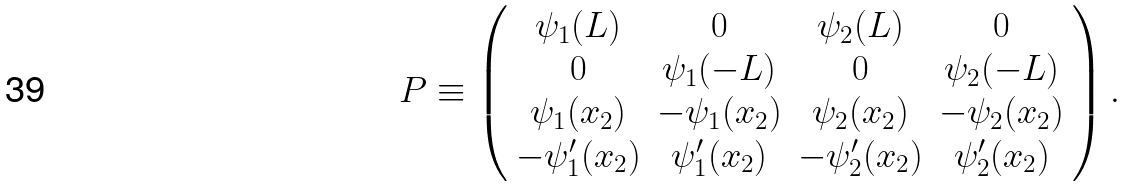Convert formula to latex. <formula><loc_0><loc_0><loc_500><loc_500>P \equiv \left ( \begin{array} { c c c c } \psi _ { 1 } ( L ) & 0 & \psi _ { 2 } ( L ) & 0 \\ 0 & \psi _ { 1 } ( - L ) & 0 & \psi _ { 2 } ( - L ) \\ \psi _ { 1 } ( x _ { 2 } ) & - \psi _ { 1 } ( x _ { 2 } ) & \psi _ { 2 } ( x _ { 2 } ) & - \psi _ { 2 } ( x _ { 2 } ) \\ - \psi _ { 1 } ^ { \prime } ( x _ { 2 } ) & \psi _ { 1 } ^ { \prime } ( x _ { 2 } ) & - \psi _ { 2 } ^ { \prime } ( x _ { 2 } ) & \psi _ { 2 } ^ { \prime } ( x _ { 2 } ) \end{array} \right ) .</formula> 